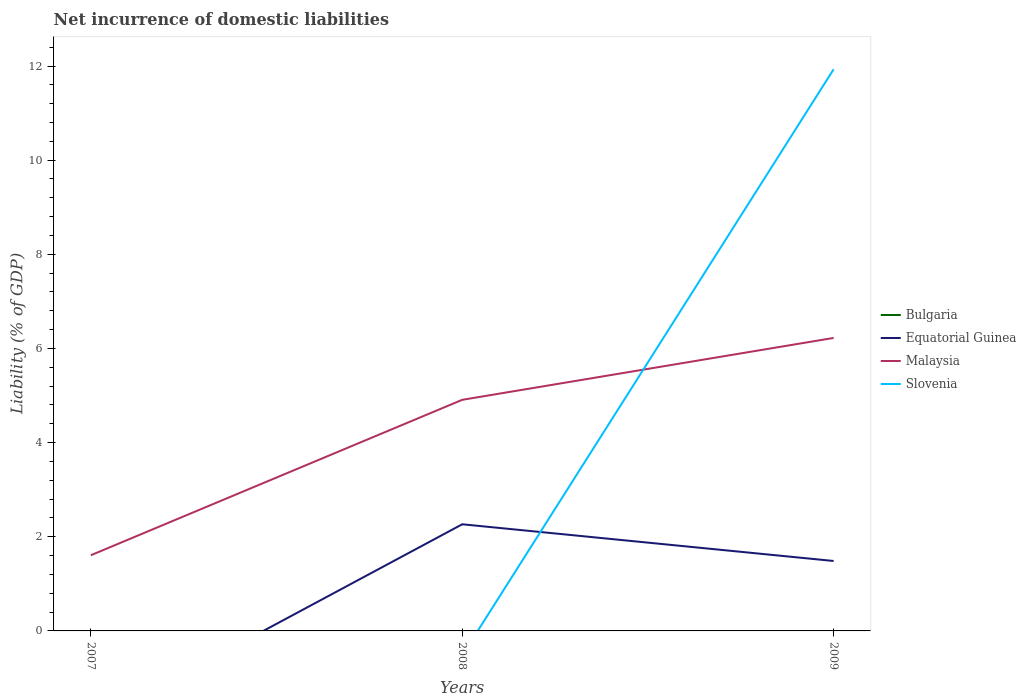How many different coloured lines are there?
Make the answer very short. 3. Does the line corresponding to Equatorial Guinea intersect with the line corresponding to Bulgaria?
Ensure brevity in your answer.  Yes. Across all years, what is the maximum net incurrence of domestic liabilities in Bulgaria?
Offer a terse response. 0. What is the total net incurrence of domestic liabilities in Malaysia in the graph?
Keep it short and to the point. -1.31. What is the difference between the highest and the second highest net incurrence of domestic liabilities in Malaysia?
Make the answer very short. 4.62. Is the net incurrence of domestic liabilities in Bulgaria strictly greater than the net incurrence of domestic liabilities in Slovenia over the years?
Make the answer very short. No. How many years are there in the graph?
Your answer should be compact. 3. Are the values on the major ticks of Y-axis written in scientific E-notation?
Ensure brevity in your answer.  No. Where does the legend appear in the graph?
Provide a succinct answer. Center right. How many legend labels are there?
Offer a terse response. 4. How are the legend labels stacked?
Provide a short and direct response. Vertical. What is the title of the graph?
Offer a very short reply. Net incurrence of domestic liabilities. Does "Palau" appear as one of the legend labels in the graph?
Give a very brief answer. No. What is the label or title of the Y-axis?
Your answer should be compact. Liability (% of GDP). What is the Liability (% of GDP) of Malaysia in 2007?
Give a very brief answer. 1.61. What is the Liability (% of GDP) of Equatorial Guinea in 2008?
Provide a succinct answer. 2.27. What is the Liability (% of GDP) in Malaysia in 2008?
Ensure brevity in your answer.  4.91. What is the Liability (% of GDP) of Slovenia in 2008?
Offer a terse response. 0. What is the Liability (% of GDP) of Equatorial Guinea in 2009?
Keep it short and to the point. 1.49. What is the Liability (% of GDP) of Malaysia in 2009?
Offer a very short reply. 6.22. What is the Liability (% of GDP) of Slovenia in 2009?
Your answer should be compact. 11.93. Across all years, what is the maximum Liability (% of GDP) in Equatorial Guinea?
Ensure brevity in your answer.  2.27. Across all years, what is the maximum Liability (% of GDP) of Malaysia?
Your answer should be compact. 6.22. Across all years, what is the maximum Liability (% of GDP) of Slovenia?
Give a very brief answer. 11.93. Across all years, what is the minimum Liability (% of GDP) of Equatorial Guinea?
Keep it short and to the point. 0. Across all years, what is the minimum Liability (% of GDP) of Malaysia?
Your answer should be very brief. 1.61. Across all years, what is the minimum Liability (% of GDP) in Slovenia?
Your answer should be very brief. 0. What is the total Liability (% of GDP) in Equatorial Guinea in the graph?
Keep it short and to the point. 3.75. What is the total Liability (% of GDP) of Malaysia in the graph?
Offer a terse response. 12.74. What is the total Liability (% of GDP) in Slovenia in the graph?
Provide a short and direct response. 11.93. What is the difference between the Liability (% of GDP) of Malaysia in 2007 and that in 2008?
Offer a terse response. -3.3. What is the difference between the Liability (% of GDP) in Malaysia in 2007 and that in 2009?
Offer a very short reply. -4.62. What is the difference between the Liability (% of GDP) of Equatorial Guinea in 2008 and that in 2009?
Your answer should be compact. 0.78. What is the difference between the Liability (% of GDP) in Malaysia in 2008 and that in 2009?
Keep it short and to the point. -1.31. What is the difference between the Liability (% of GDP) in Malaysia in 2007 and the Liability (% of GDP) in Slovenia in 2009?
Ensure brevity in your answer.  -10.32. What is the difference between the Liability (% of GDP) of Equatorial Guinea in 2008 and the Liability (% of GDP) of Malaysia in 2009?
Your response must be concise. -3.96. What is the difference between the Liability (% of GDP) of Equatorial Guinea in 2008 and the Liability (% of GDP) of Slovenia in 2009?
Your answer should be compact. -9.66. What is the difference between the Liability (% of GDP) in Malaysia in 2008 and the Liability (% of GDP) in Slovenia in 2009?
Offer a terse response. -7.02. What is the average Liability (% of GDP) of Equatorial Guinea per year?
Offer a terse response. 1.25. What is the average Liability (% of GDP) of Malaysia per year?
Ensure brevity in your answer.  4.25. What is the average Liability (% of GDP) of Slovenia per year?
Provide a succinct answer. 3.98. In the year 2008, what is the difference between the Liability (% of GDP) of Equatorial Guinea and Liability (% of GDP) of Malaysia?
Provide a succinct answer. -2.64. In the year 2009, what is the difference between the Liability (% of GDP) in Equatorial Guinea and Liability (% of GDP) in Malaysia?
Offer a terse response. -4.74. In the year 2009, what is the difference between the Liability (% of GDP) in Equatorial Guinea and Liability (% of GDP) in Slovenia?
Your answer should be compact. -10.44. In the year 2009, what is the difference between the Liability (% of GDP) of Malaysia and Liability (% of GDP) of Slovenia?
Your response must be concise. -5.71. What is the ratio of the Liability (% of GDP) of Malaysia in 2007 to that in 2008?
Make the answer very short. 0.33. What is the ratio of the Liability (% of GDP) of Malaysia in 2007 to that in 2009?
Offer a terse response. 0.26. What is the ratio of the Liability (% of GDP) of Equatorial Guinea in 2008 to that in 2009?
Make the answer very short. 1.52. What is the ratio of the Liability (% of GDP) of Malaysia in 2008 to that in 2009?
Give a very brief answer. 0.79. What is the difference between the highest and the second highest Liability (% of GDP) in Malaysia?
Offer a terse response. 1.31. What is the difference between the highest and the lowest Liability (% of GDP) in Equatorial Guinea?
Offer a very short reply. 2.27. What is the difference between the highest and the lowest Liability (% of GDP) in Malaysia?
Offer a very short reply. 4.62. What is the difference between the highest and the lowest Liability (% of GDP) of Slovenia?
Your answer should be compact. 11.93. 